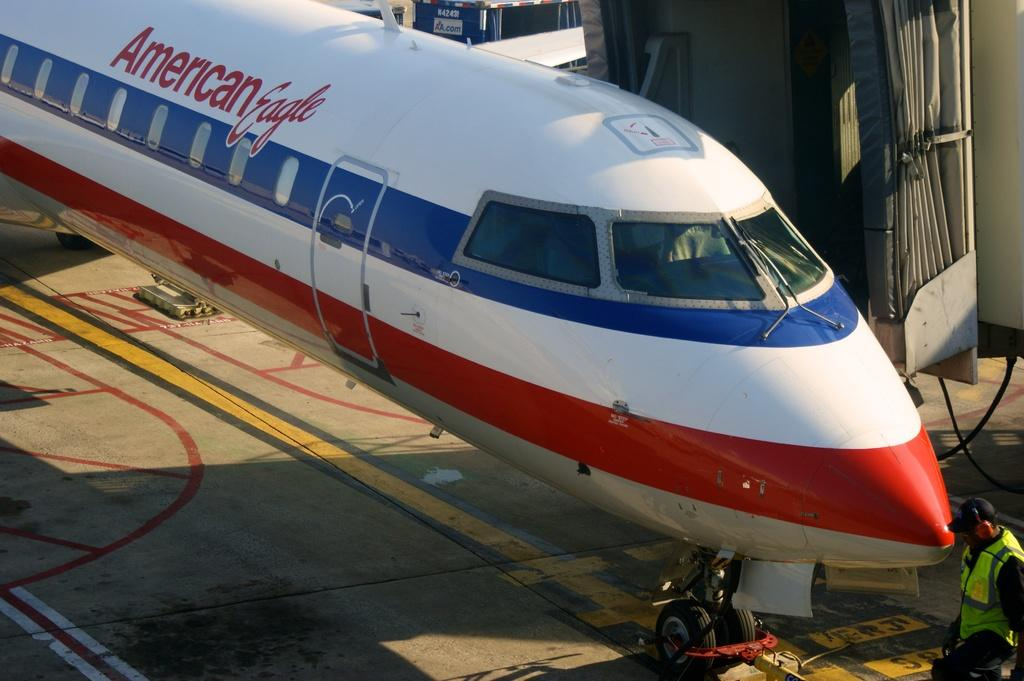What is the main subject in the center of the image? There is an airplane in the center of the image. Can you describe the person at the bottom of the image? There is a person at the bottom of the image, but their appearance or actions are not specified. What can be seen between the airplane and the person? There is a walkway in the image. What is visible in the background of the image? There are machines and objects with wires in the background of the image. What type of society is depicted in the image? The image does not depict a society; it features an airplane, a person, a walkway, and objects in the background. Can you see a swing in the image? No, there is no swing present in the image. 